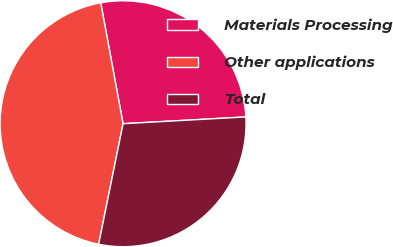Convert chart to OTSL. <chart><loc_0><loc_0><loc_500><loc_500><pie_chart><fcel>Materials Processing<fcel>Other applications<fcel>Total<nl><fcel>27.03%<fcel>43.91%<fcel>29.06%<nl></chart> 